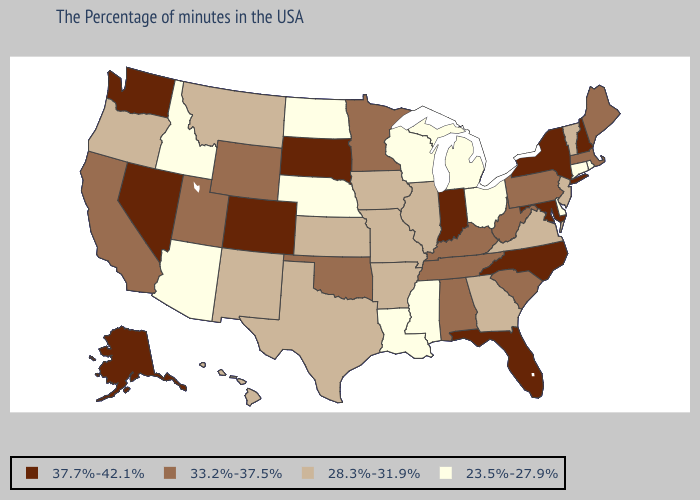Does the map have missing data?
Concise answer only. No. Name the states that have a value in the range 37.7%-42.1%?
Answer briefly. New Hampshire, New York, Maryland, North Carolina, Florida, Indiana, South Dakota, Colorado, Nevada, Washington, Alaska. Does New York have the highest value in the USA?
Short answer required. Yes. Does Kentucky have a lower value than Alaska?
Be succinct. Yes. Name the states that have a value in the range 28.3%-31.9%?
Quick response, please. Vermont, New Jersey, Virginia, Georgia, Illinois, Missouri, Arkansas, Iowa, Kansas, Texas, New Mexico, Montana, Oregon, Hawaii. Which states have the highest value in the USA?
Answer briefly. New Hampshire, New York, Maryland, North Carolina, Florida, Indiana, South Dakota, Colorado, Nevada, Washington, Alaska. Among the states that border New Hampshire , which have the lowest value?
Give a very brief answer. Vermont. What is the lowest value in the USA?
Keep it brief. 23.5%-27.9%. Does the first symbol in the legend represent the smallest category?
Keep it brief. No. Name the states that have a value in the range 23.5%-27.9%?
Give a very brief answer. Rhode Island, Connecticut, Delaware, Ohio, Michigan, Wisconsin, Mississippi, Louisiana, Nebraska, North Dakota, Arizona, Idaho. Does Rhode Island have the lowest value in the Northeast?
Be succinct. Yes. Name the states that have a value in the range 28.3%-31.9%?
Short answer required. Vermont, New Jersey, Virginia, Georgia, Illinois, Missouri, Arkansas, Iowa, Kansas, Texas, New Mexico, Montana, Oregon, Hawaii. What is the highest value in the Northeast ?
Quick response, please. 37.7%-42.1%. Name the states that have a value in the range 23.5%-27.9%?
Concise answer only. Rhode Island, Connecticut, Delaware, Ohio, Michigan, Wisconsin, Mississippi, Louisiana, Nebraska, North Dakota, Arizona, Idaho. What is the lowest value in the USA?
Give a very brief answer. 23.5%-27.9%. 